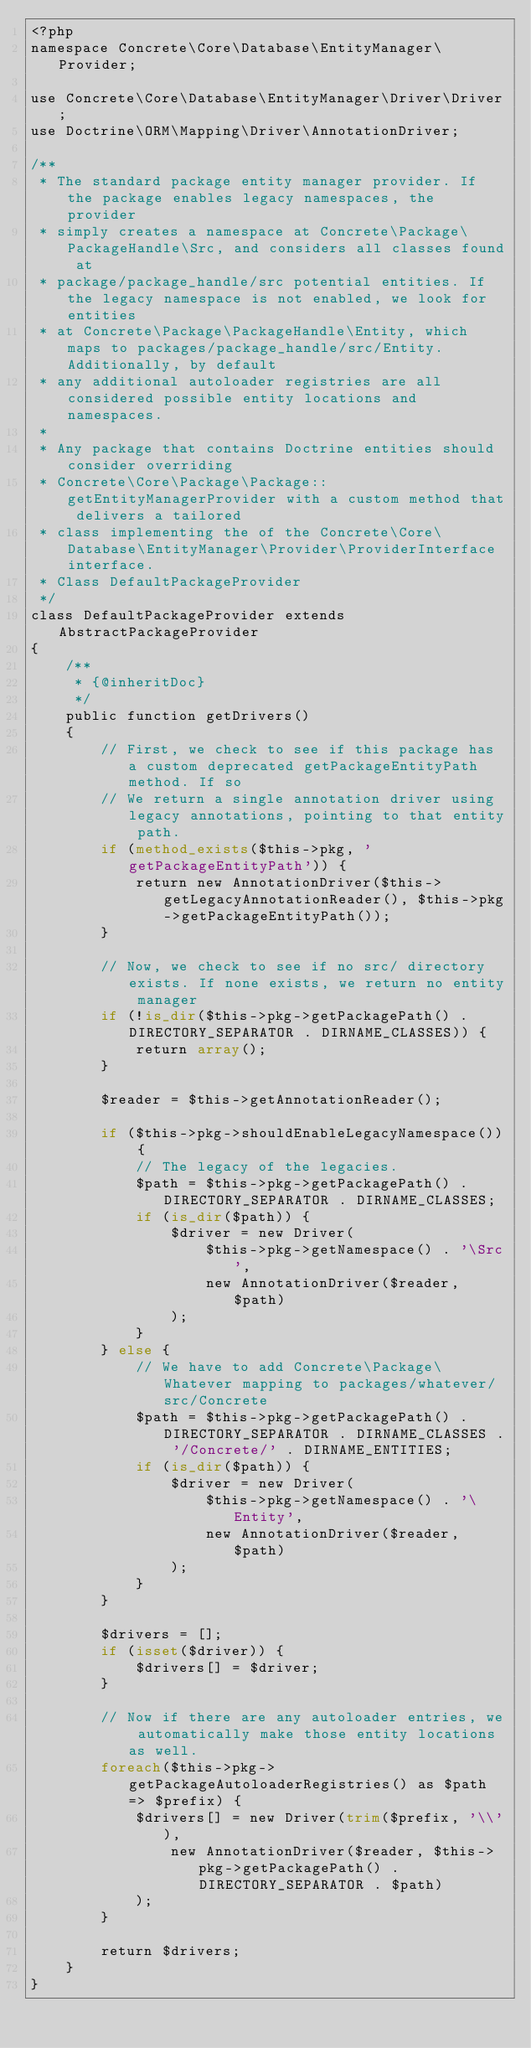<code> <loc_0><loc_0><loc_500><loc_500><_PHP_><?php
namespace Concrete\Core\Database\EntityManager\Provider;

use Concrete\Core\Database\EntityManager\Driver\Driver;
use Doctrine\ORM\Mapping\Driver\AnnotationDriver;

/**
 * The standard package entity manager provider. If the package enables legacy namespaces, the provider
 * simply creates a namespace at Concrete\Package\PackageHandle\Src, and considers all classes found at
 * package/package_handle/src potential entities. If the legacy namespace is not enabled, we look for entities
 * at Concrete\Package\PackageHandle\Entity, which maps to packages/package_handle/src/Entity. Additionally, by default
 * any additional autoloader registries are all considered possible entity locations and namespaces.
 *
 * Any package that contains Doctrine entities should consider overriding
 * Concrete\Core\Package\Package::getEntityManagerProvider with a custom method that delivers a tailored
 * class implementing the of the Concrete\Core\Database\EntityManager\Provider\ProviderInterface interface.
 * Class DefaultPackageProvider
 */
class DefaultPackageProvider extends AbstractPackageProvider
{
    /**
     * {@inheritDoc}
     */
    public function getDrivers()
    {
        // First, we check to see if this package has a custom deprecated getPackageEntityPath method. If so
        // We return a single annotation driver using legacy annotations, pointing to that entity path.
        if (method_exists($this->pkg, 'getPackageEntityPath')) {
            return new AnnotationDriver($this->getLegacyAnnotationReader(), $this->pkg->getPackageEntityPath());
        }

        // Now, we check to see if no src/ directory exists. If none exists, we return no entity manager
        if (!is_dir($this->pkg->getPackagePath() . DIRECTORY_SEPARATOR . DIRNAME_CLASSES)) {
            return array();
        }

        $reader = $this->getAnnotationReader();

        if ($this->pkg->shouldEnableLegacyNamespace()) {
            // The legacy of the legacies.
            $path = $this->pkg->getPackagePath() . DIRECTORY_SEPARATOR . DIRNAME_CLASSES;
            if (is_dir($path)) {
                $driver = new Driver(
                    $this->pkg->getNamespace() . '\Src',
                    new AnnotationDriver($reader, $path)
                );
            }
        } else {
            // We have to add Concrete\Package\Whatever mapping to packages/whatever/src/Concrete
            $path = $this->pkg->getPackagePath() . DIRECTORY_SEPARATOR . DIRNAME_CLASSES . '/Concrete/' . DIRNAME_ENTITIES;
            if (is_dir($path)) {
                $driver = new Driver(
                    $this->pkg->getNamespace() . '\Entity',
                    new AnnotationDriver($reader, $path)
                );
            }
        }

        $drivers = [];
        if (isset($driver)) {
            $drivers[] = $driver;
        }

        // Now if there are any autoloader entries, we automatically make those entity locations as well.
        foreach($this->pkg->getPackageAutoloaderRegistries() as $path => $prefix) {
            $drivers[] = new Driver(trim($prefix, '\\'),
                new AnnotationDriver($reader, $this->pkg->getPackagePath() . DIRECTORY_SEPARATOR . $path)
            );
        }

        return $drivers;
    }
}
</code> 